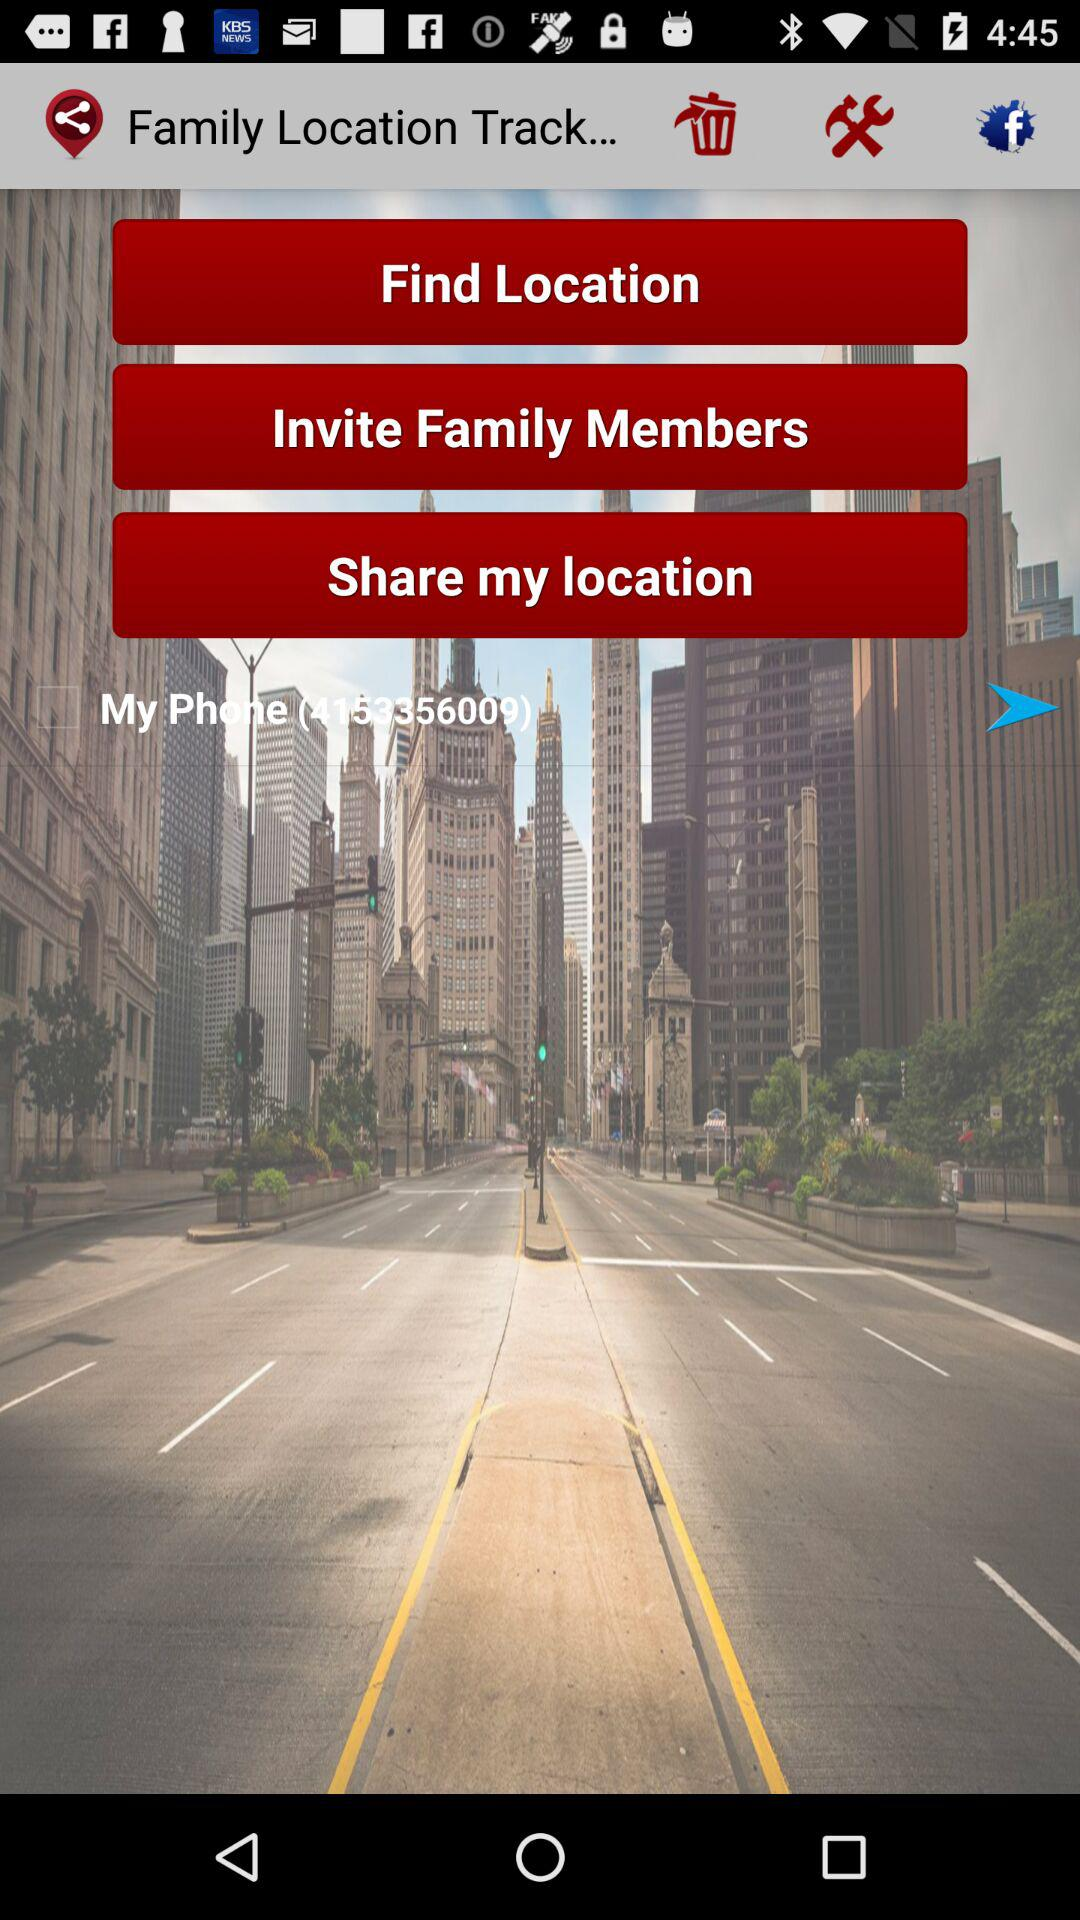What is the contact number? The contact number is 4153356009. 